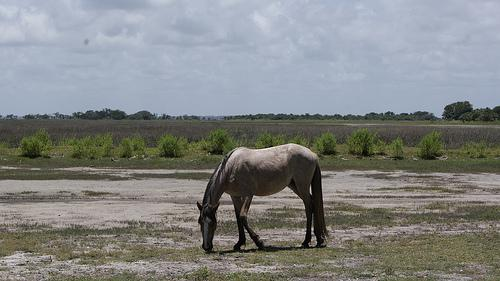Question: where are the clouds?
Choices:
A. In the sky.
B. Overhead.
C. Approaching.
D. On the horizon.
Answer with the letter. Answer: A Question: what is in the sky?
Choices:
A. Clouds.
B. Stars.
C. The sun.
D. A plane.
Answer with the letter. Answer: A 